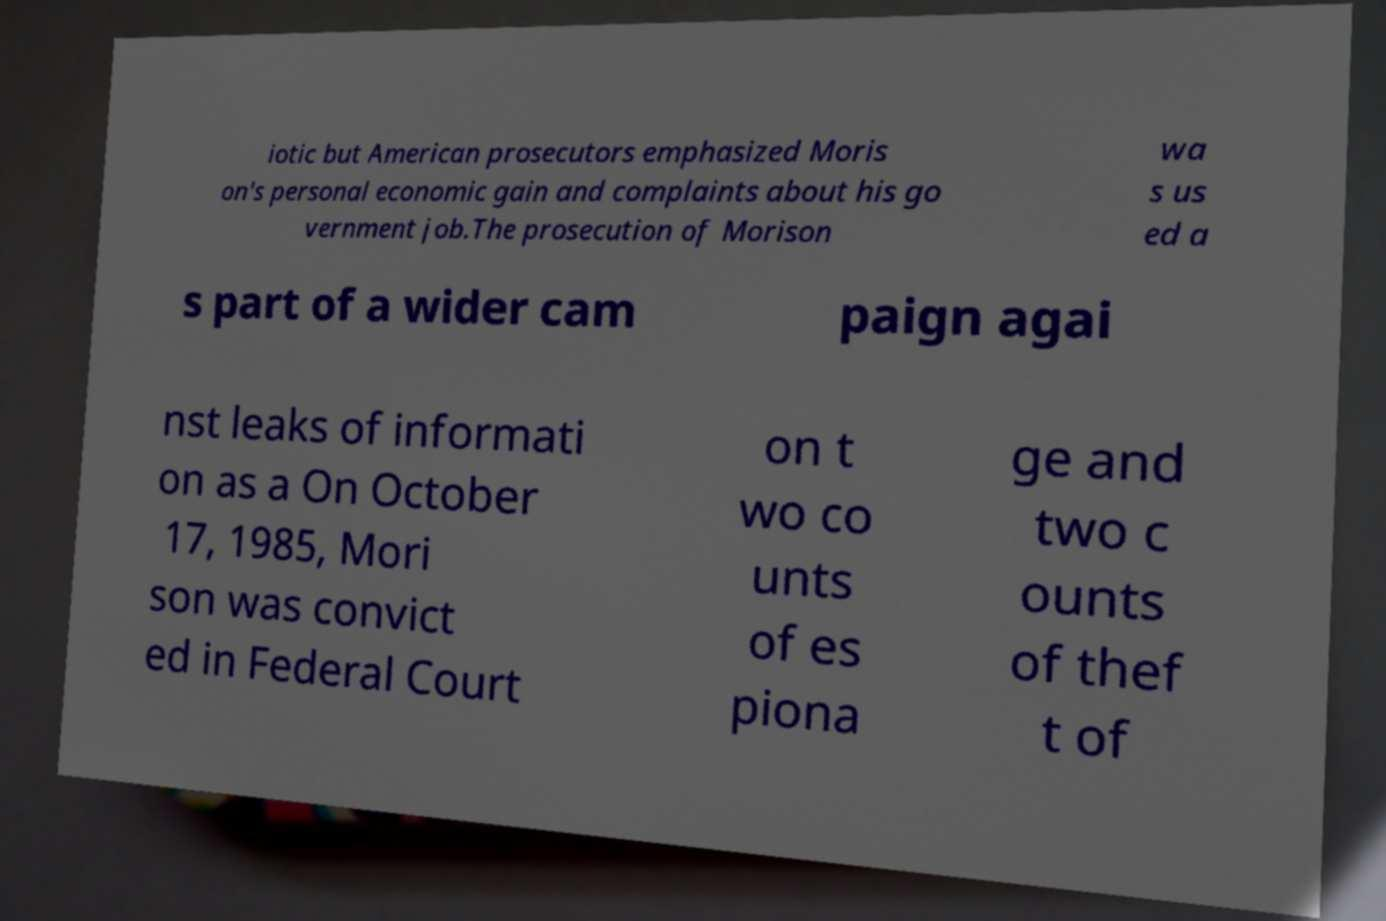For documentation purposes, I need the text within this image transcribed. Could you provide that? iotic but American prosecutors emphasized Moris on's personal economic gain and complaints about his go vernment job.The prosecution of Morison wa s us ed a s part of a wider cam paign agai nst leaks of informati on as a On October 17, 1985, Mori son was convict ed in Federal Court on t wo co unts of es piona ge and two c ounts of thef t of 